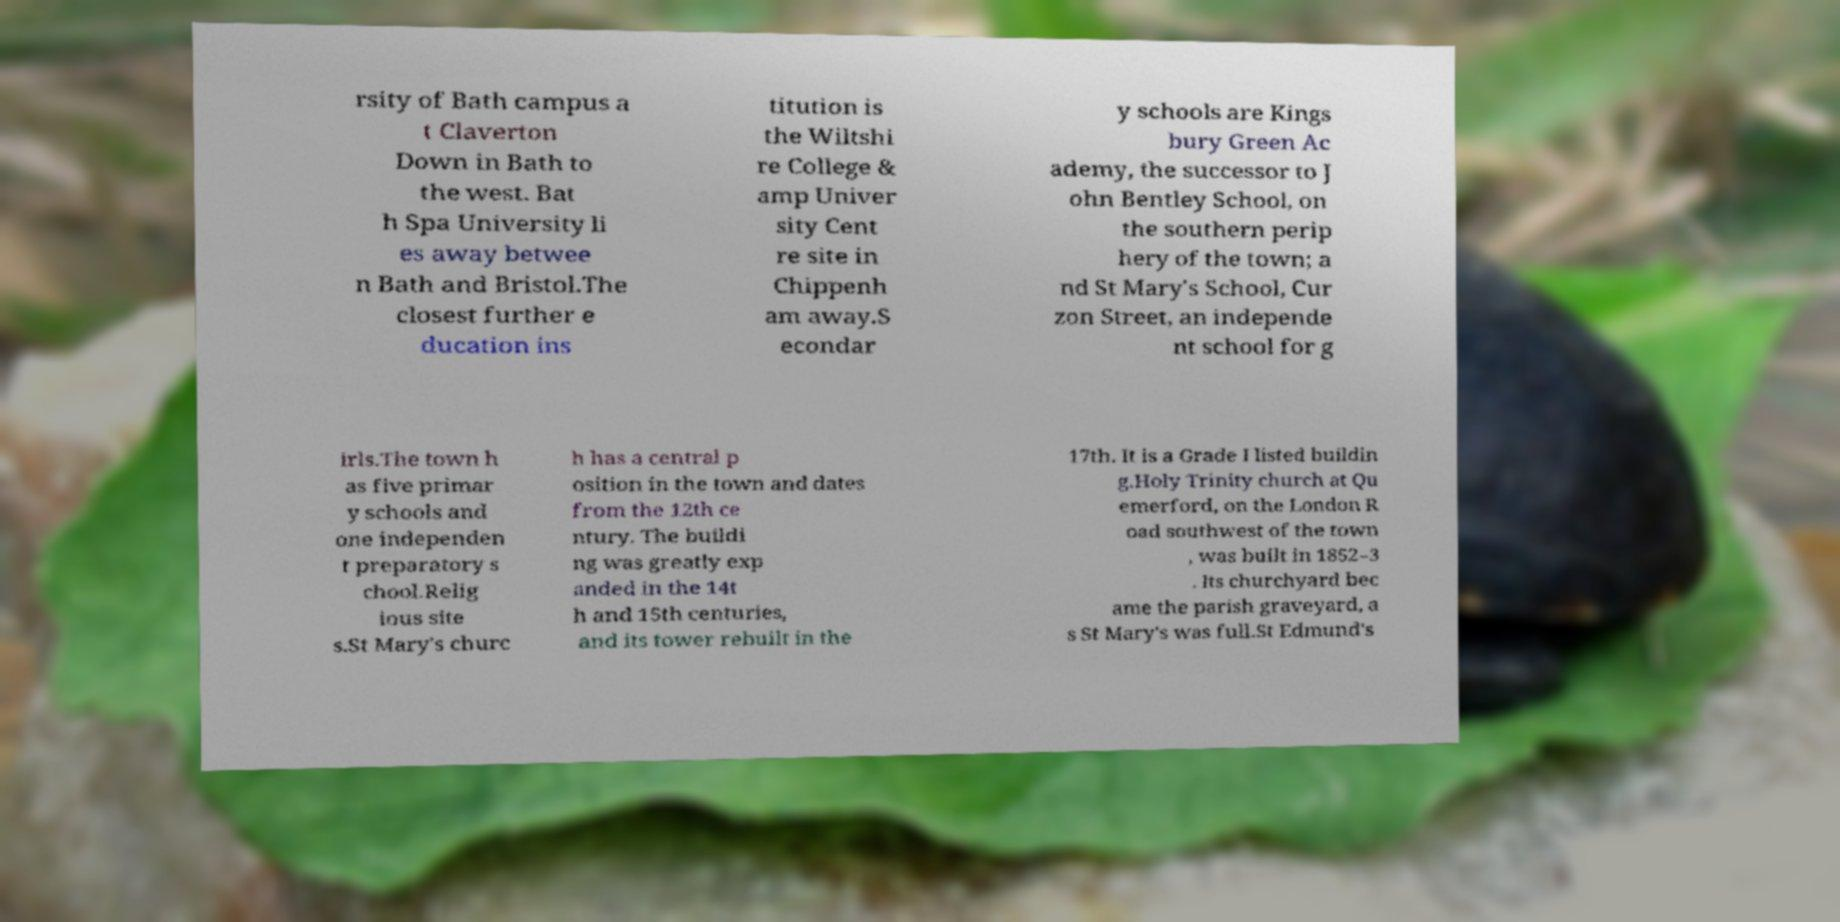Could you extract and type out the text from this image? rsity of Bath campus a t Claverton Down in Bath to the west. Bat h Spa University li es away betwee n Bath and Bristol.The closest further e ducation ins titution is the Wiltshi re College & amp Univer sity Cent re site in Chippenh am away.S econdar y schools are Kings bury Green Ac ademy, the successor to J ohn Bentley School, on the southern perip hery of the town; a nd St Mary's School, Cur zon Street, an independe nt school for g irls.The town h as five primar y schools and one independen t preparatory s chool.Relig ious site s.St Mary's churc h has a central p osition in the town and dates from the 12th ce ntury. The buildi ng was greatly exp anded in the 14t h and 15th centuries, and its tower rebuilt in the 17th. It is a Grade I listed buildin g.Holy Trinity church at Qu emerford, on the London R oad southwest of the town , was built in 1852–3 . Its churchyard bec ame the parish graveyard, a s St Mary's was full.St Edmund's 